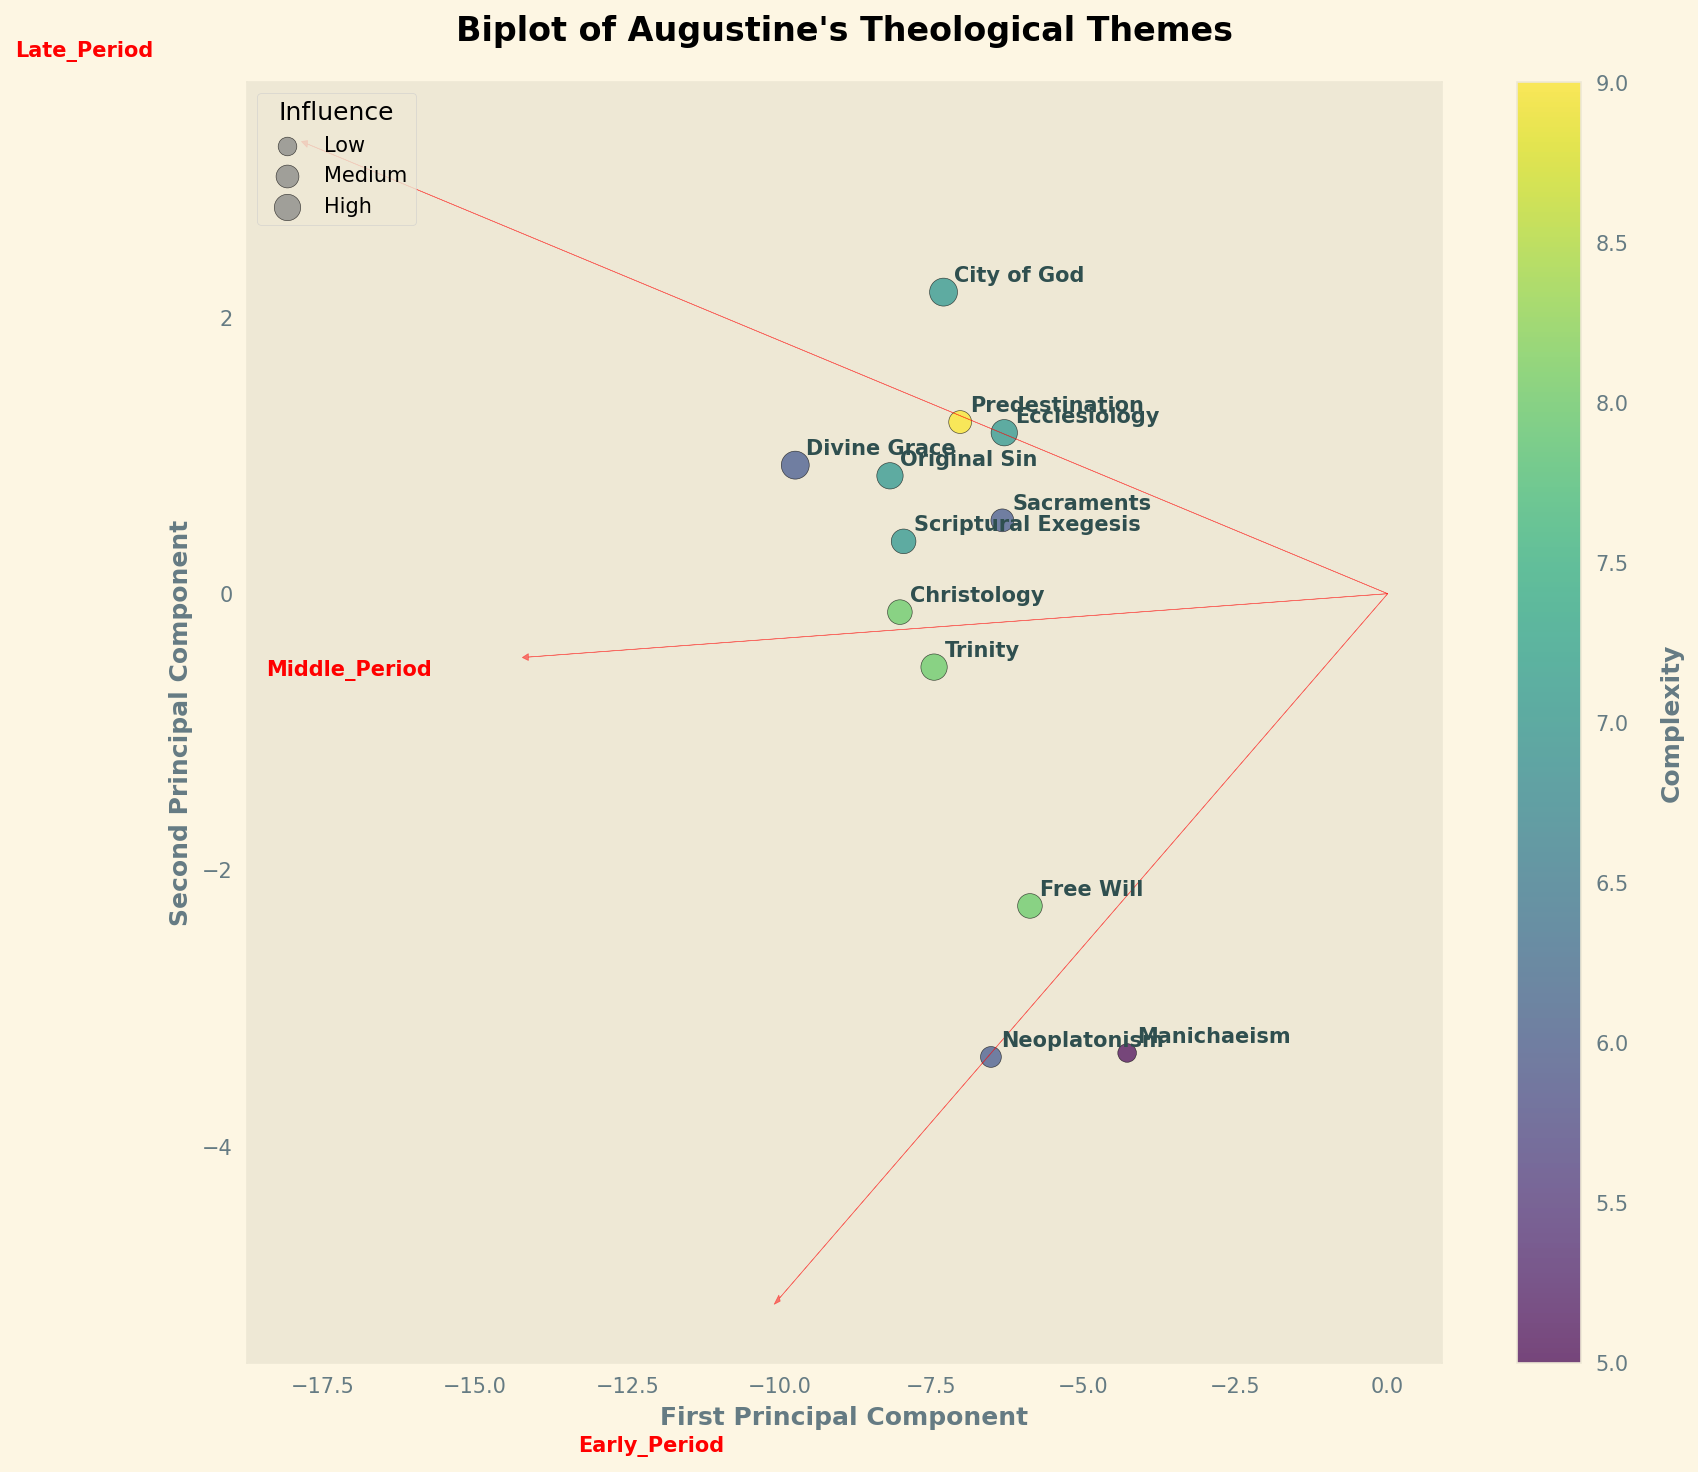What is the title of the figure? The title can be found at the top of the figure. It is written in bold and larger font compared to other texts on the figure.
Answer: Biplot of Augustine's Theological Themes How many themes are represented in the biplot? Count the number of data points or annotated labels in the figure. Each label represents one theme.
Answer: 12 Which theme shows the highest complexity? Complexity is represented by the color in the scatter plot. Find the data point with the darkest color.
Answer: Divine Grace Which theme shows the lowest influence? Influence is represented by the size of the datapoints. Find the data point with the smallest size.
Answer: Manichaeism Which two themes are nearest to each other on the plot? Look for the two points that are closest in proximity on the scatter plot. Consider both x and y coordinates.
Answer: Free Will and Neoplatonism What is the general trend of the "Original Sin" theme over the three periods of Augustine's life? Observe the position of the "Original Sin" label in relation to the principal components. Usually, the placement indicates the trend over periods.
Answer: Increasing Compare the positions of "City of God" and "Christology" on the plot. Which period's influence is more prominent for each theme? Check the x and y coordinates for both "City of God" and "Christology" and note their relative position along both axes.
Answer: "City of God" is more influenced in the Late Period, whereas "Christology" is more balanced Does the figure suggest any correlation between complexity and influence of the themes? Correlations can be inferred by examining if larger sizes (representing higher influence) correspond to darker colors (representing higher complexity).
Answer: Yes, there seems to be a positive correlation Which arrows in the variable loadings point more towards the first principal component? Identify the arrows that are more closely aligned with the x-axis (horizontal direction).
Answer: Early_Period and Late_Period How does the "Trinity" theme compare to the "Predestination" theme in terms of their principal components? Compare the x and y coordinates of both themes on the scatter plot to see how they relate to the first and second principal components.
Answer: Trinity has a higher value on the first principal component and lower on the second compared to Predestination 